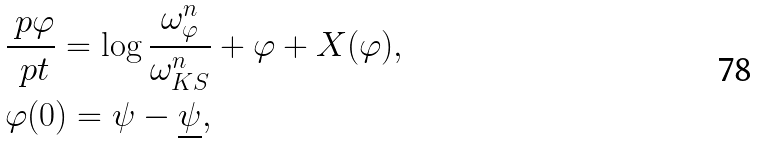<formula> <loc_0><loc_0><loc_500><loc_500>& \frac { \ p \varphi } { \ p t } = \log \frac { \omega ^ { n } _ { \varphi } } { \omega _ { K S } ^ { n } } + \varphi + X ( \varphi ) , \\ & \varphi ( 0 ) = \psi - \underline { \psi } ,</formula> 